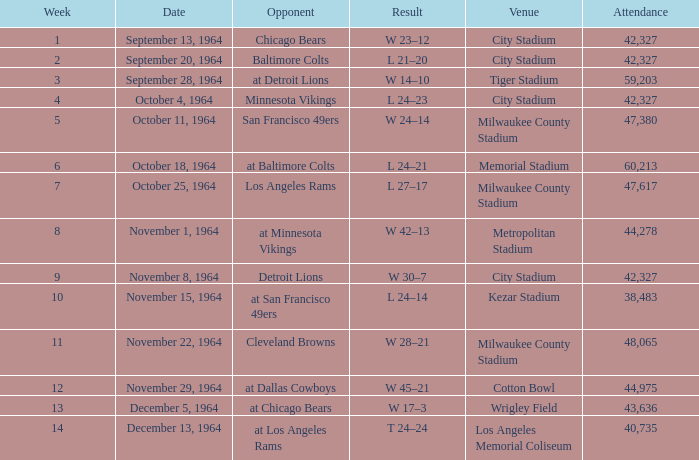In which place was the game with a 24-14 outcome held? Kezar Stadium. 